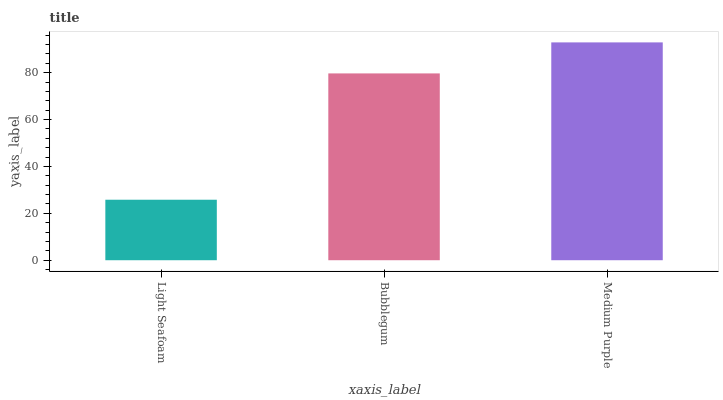Is Bubblegum the minimum?
Answer yes or no. No. Is Bubblegum the maximum?
Answer yes or no. No. Is Bubblegum greater than Light Seafoam?
Answer yes or no. Yes. Is Light Seafoam less than Bubblegum?
Answer yes or no. Yes. Is Light Seafoam greater than Bubblegum?
Answer yes or no. No. Is Bubblegum less than Light Seafoam?
Answer yes or no. No. Is Bubblegum the high median?
Answer yes or no. Yes. Is Bubblegum the low median?
Answer yes or no. Yes. Is Medium Purple the high median?
Answer yes or no. No. Is Medium Purple the low median?
Answer yes or no. No. 